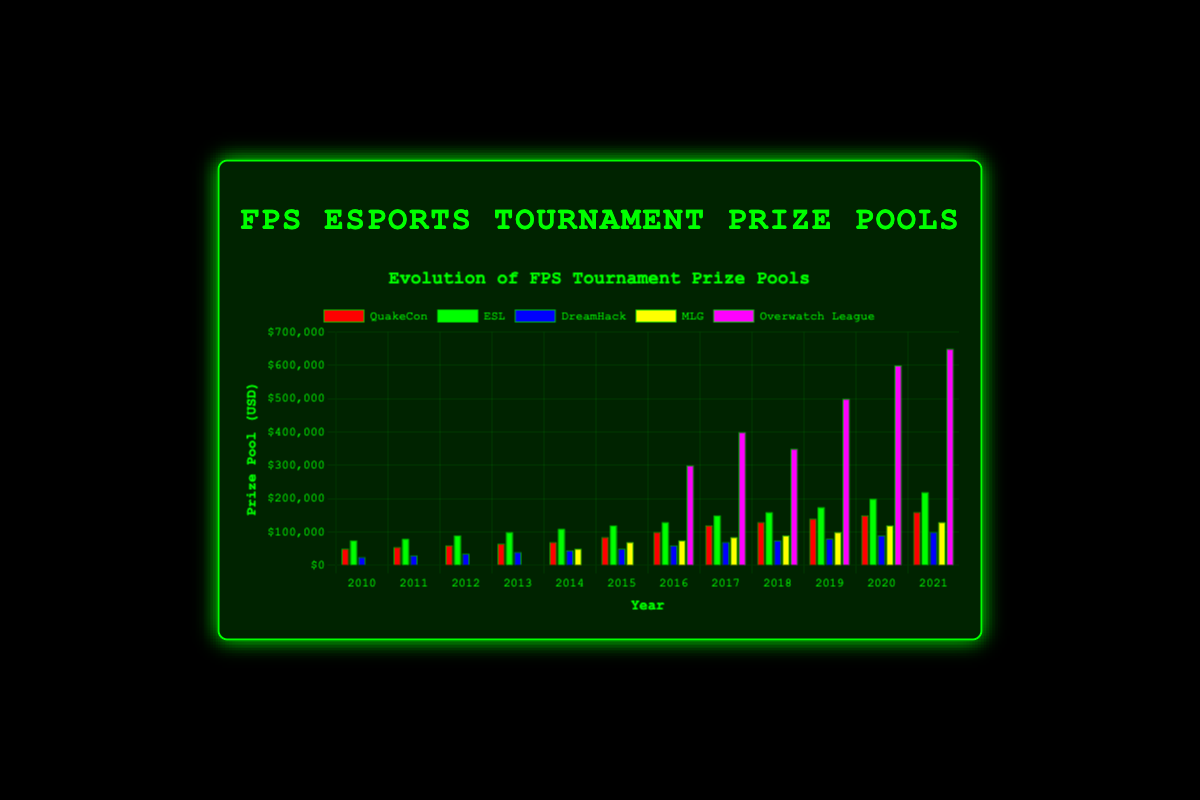How does the prize pool for QuakeCon in 2021 compare to its prize pool in 2010? Look at the bar corresponding to QuakeCon for 2021 (highest bar of the group) and compare its height to the bar for 2010 (smallest bar of the group). The 2021 QuakeCon prize pool is clearly higher.
Answer: It increased by $110,000 Which tournament had the largest prize pool in 2016 and how much was it? Find the highest bar in 2016 and check its label. That highest bar corresponds to the Overwatch League.
Answer: Overwatch League with $300,000 Which year did ESL see the highest prize pool and how much was it? Locate the tallest ESL bar by visually comparing them across the years. The biggest height falls in 2021.
Answer: 2021 with $220,000 By how much did the prize pool for Overwatch League increase from 2016 to 2019? Find the Overwatch League bars for 2016 and 2019. Calculate the difference between their heights ($500,000 - $300,000).
Answer: $200,000 What is the combined prize pool for all tournaments in 2013? Sum the heights of all 2013 bars: QuakeCon ($65,000), ESL ($100,000), and DreamHack ($40,000).
Answer: $205,000 How many years did QuakeCon have a prize pool of $100,000 or more? Identify QuakeCon bars that reach the $100,000 line or above: 2016, 2017, 2018, 2019, 2020, and 2021. Count these bars.
Answer: 6 years Which tournaments started offering prizes in 2014? Compare the 2014 bars to previous years, noting any new bars. MLG first appears in 2014.
Answer: MLG In 2015, which tournament had the lowest prize pool and what was its value? Find the shortest bar in 2015 and read its label and value. DreamHack has the smallest prize pool.
Answer: DreamHack with $50,000 What’s the average annual prize pool of MLG from 2014 to 2021? Add up the MLG prize pools for these years ($50,000, $70,000, $75,000, $85,000, $90,000, $100,000, $120,000, $130,000) and divide by the number of years (8).
Answer: $90,000 Which tournament saw the biggest single-year increase in prize pool, between which years, and what was the amount? Look for the largest bar height difference for a single tournament between consecutive years. Overwatch League from 2016 to 2017 increased by $100,000 (from $300,000 to $400,000).
Answer: Overwatch League from 2016 to 2017, $100,000 